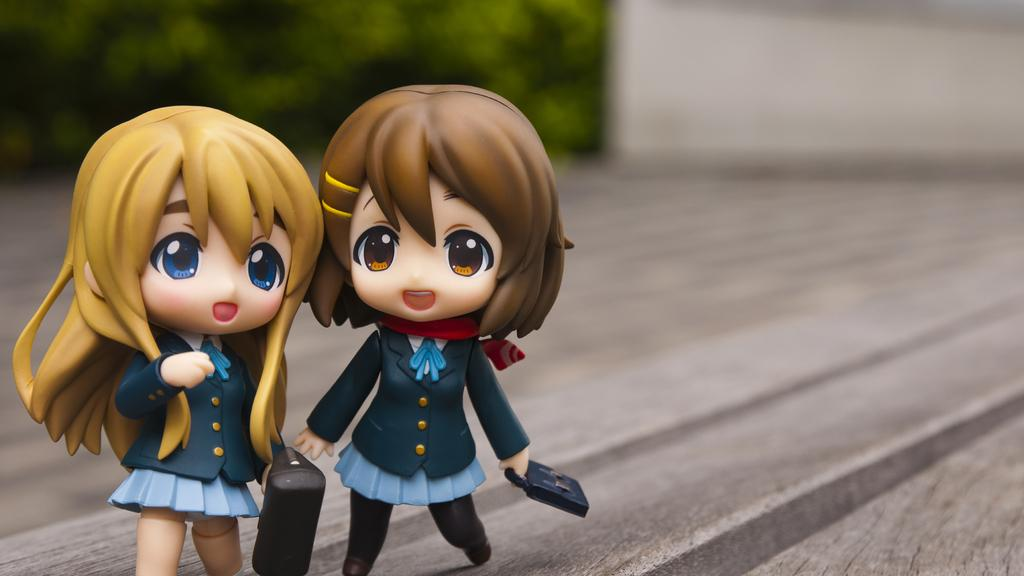How many toys are visible in the image? There are two toys in the image. What is the surface on which the toys are placed? The toys are on a wooden surface. Can you describe the background of the image? The background of the image is blurry and green. How many hands are holding the toys in the image? There is no indication in the image that any hands are holding the toys. Is there a girl wearing a mitten in the image? There is no girl or mitten present in the image. 